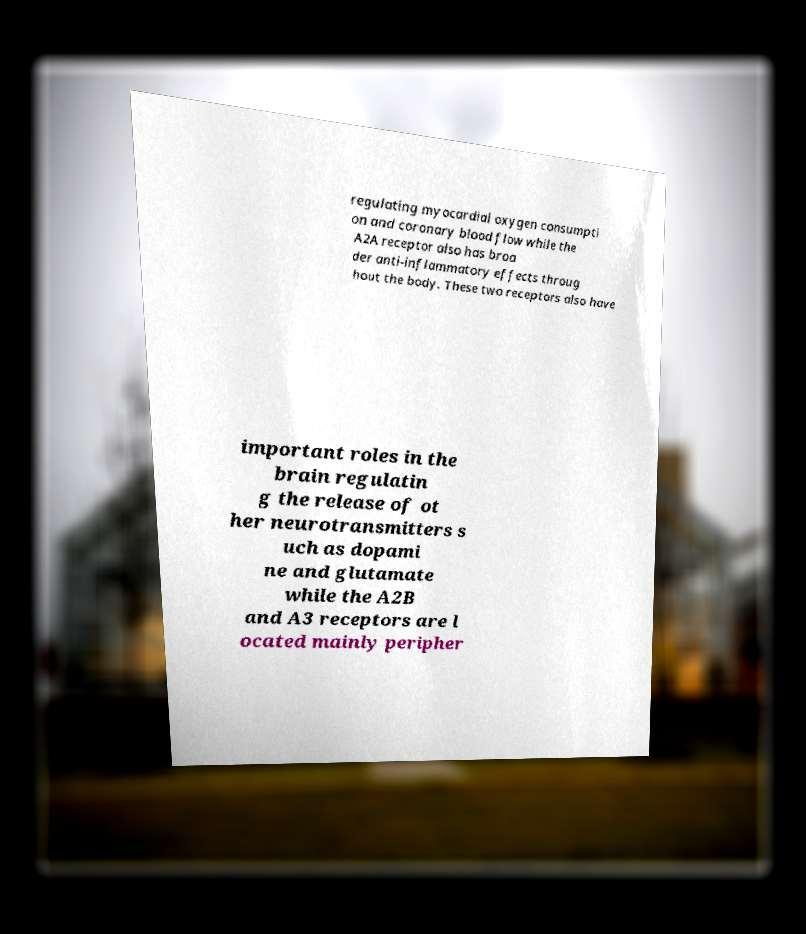Please read and relay the text visible in this image. What does it say? regulating myocardial oxygen consumpti on and coronary blood flow while the A2A receptor also has broa der anti-inflammatory effects throug hout the body. These two receptors also have important roles in the brain regulatin g the release of ot her neurotransmitters s uch as dopami ne and glutamate while the A2B and A3 receptors are l ocated mainly peripher 